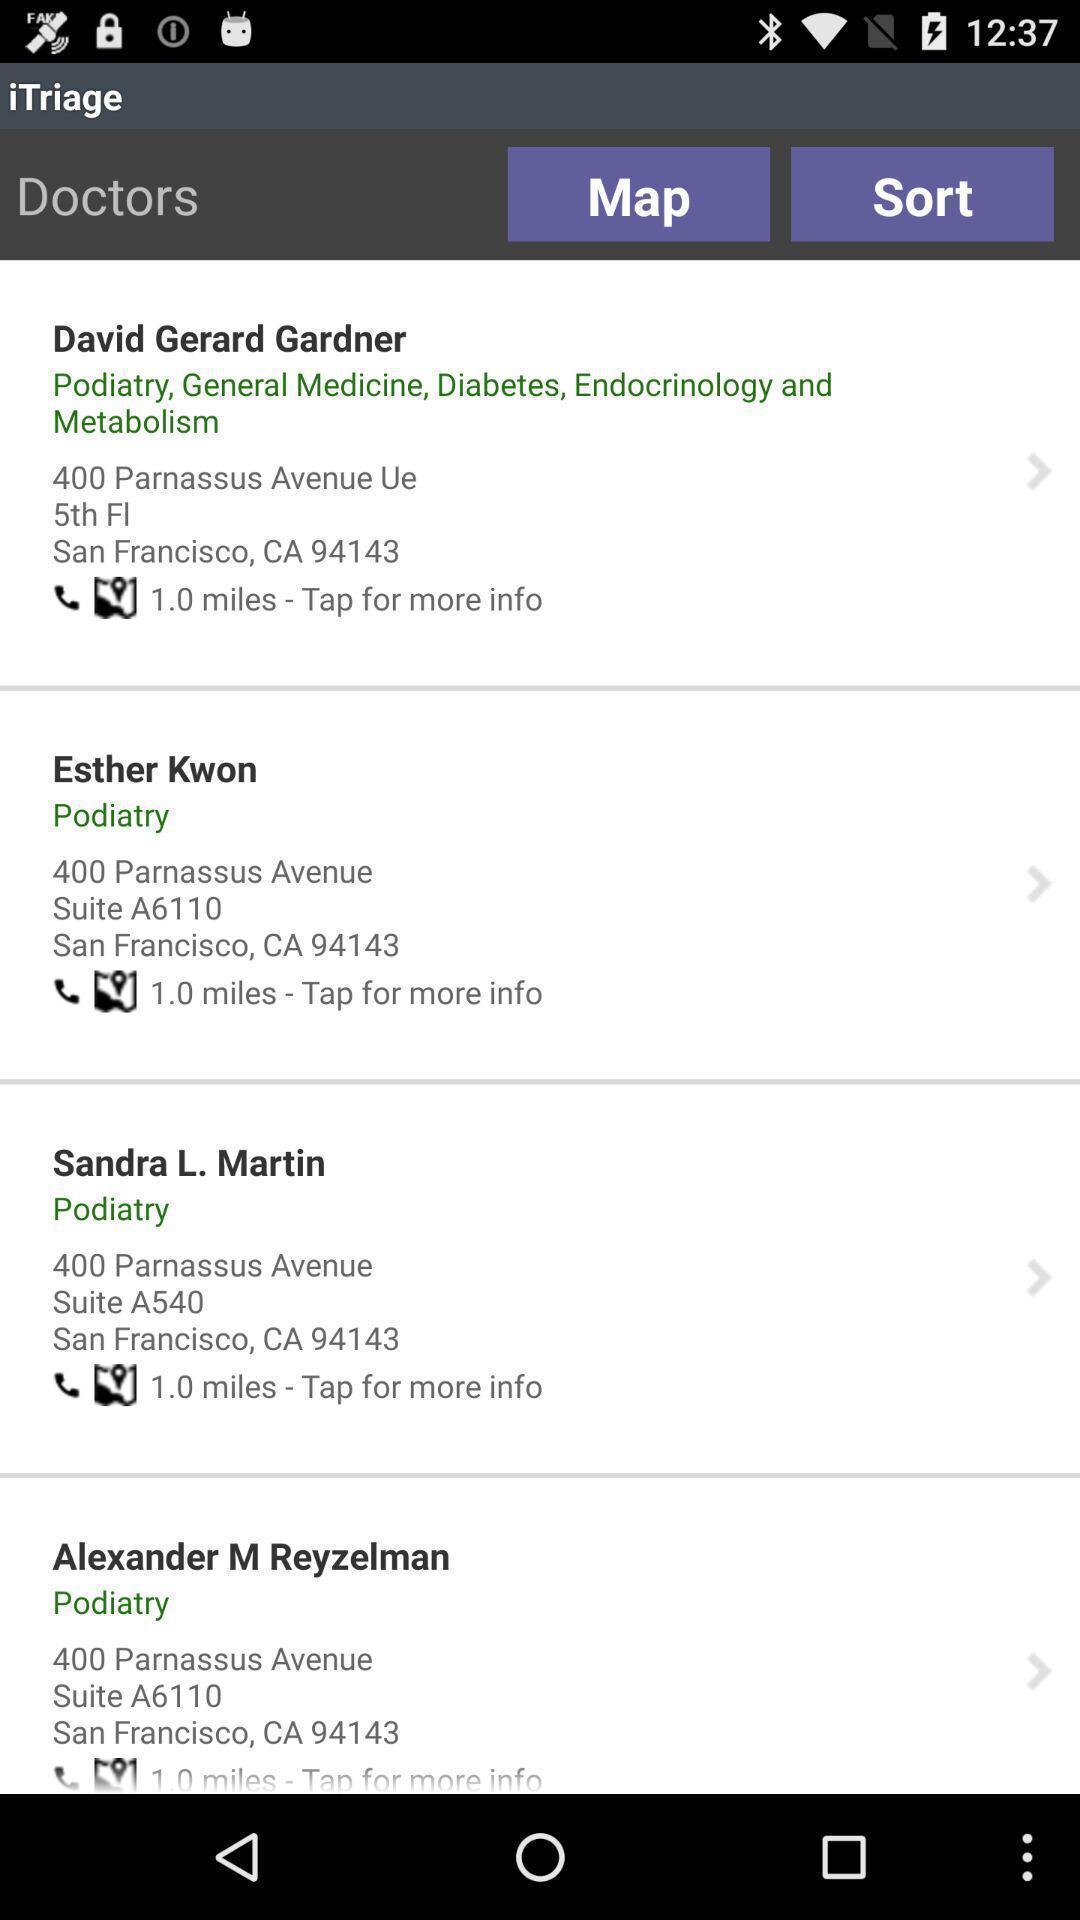Provide a textual representation of this image. Screen showing list of contacts in health app. 